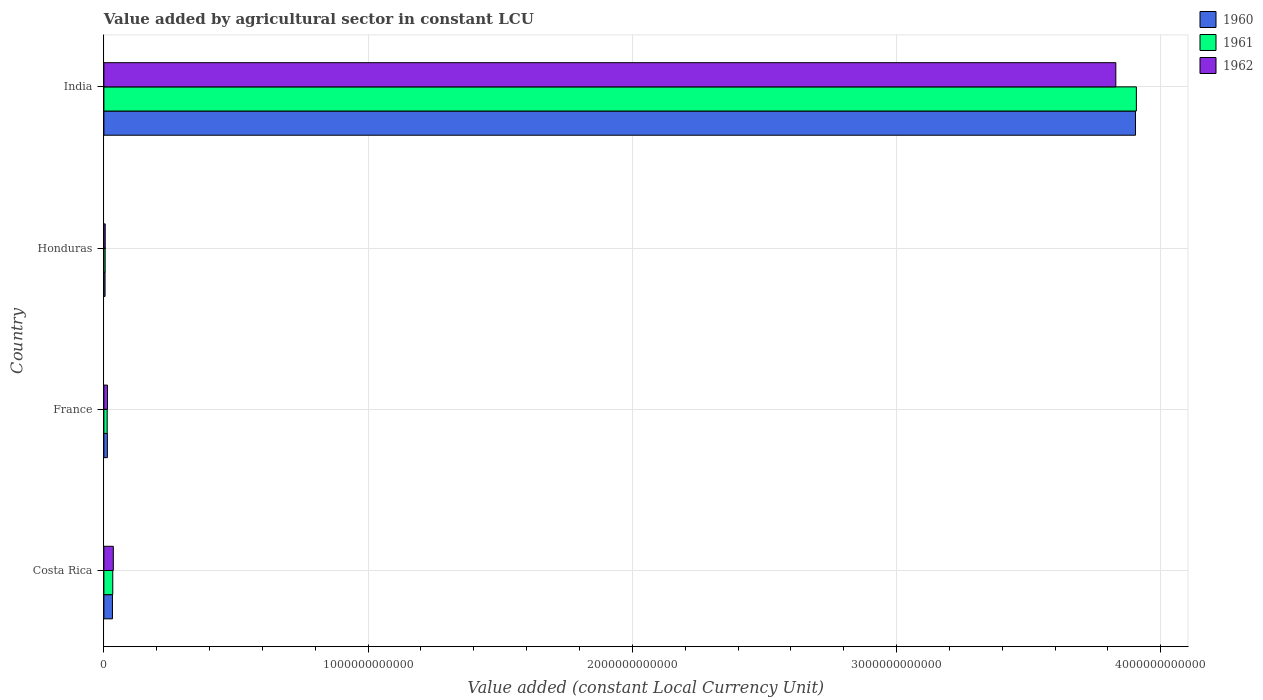Are the number of bars per tick equal to the number of legend labels?
Give a very brief answer. Yes. In how many cases, is the number of bars for a given country not equal to the number of legend labels?
Your response must be concise. 0. What is the value added by agricultural sector in 1962 in France?
Your answer should be very brief. 1.36e+1. Across all countries, what is the maximum value added by agricultural sector in 1962?
Provide a short and direct response. 3.83e+12. Across all countries, what is the minimum value added by agricultural sector in 1962?
Your answer should be compact. 4.96e+09. In which country was the value added by agricultural sector in 1960 minimum?
Give a very brief answer. Honduras. What is the total value added by agricultural sector in 1961 in the graph?
Provide a short and direct response. 3.96e+12. What is the difference between the value added by agricultural sector in 1961 in France and that in India?
Ensure brevity in your answer.  -3.90e+12. What is the difference between the value added by agricultural sector in 1961 in Honduras and the value added by agricultural sector in 1962 in France?
Your response must be concise. -8.85e+09. What is the average value added by agricultural sector in 1960 per country?
Your answer should be compact. 9.89e+11. What is the difference between the value added by agricultural sector in 1961 and value added by agricultural sector in 1960 in France?
Keep it short and to the point. -6.84e+08. In how many countries, is the value added by agricultural sector in 1960 greater than 1600000000000 LCU?
Offer a very short reply. 1. What is the ratio of the value added by agricultural sector in 1961 in France to that in Honduras?
Provide a short and direct response. 2.64. Is the value added by agricultural sector in 1962 in Costa Rica less than that in Honduras?
Your answer should be very brief. No. Is the difference between the value added by agricultural sector in 1961 in France and India greater than the difference between the value added by agricultural sector in 1960 in France and India?
Provide a succinct answer. No. What is the difference between the highest and the second highest value added by agricultural sector in 1961?
Ensure brevity in your answer.  3.87e+12. What is the difference between the highest and the lowest value added by agricultural sector in 1961?
Provide a short and direct response. 3.90e+12. Is the sum of the value added by agricultural sector in 1962 in France and India greater than the maximum value added by agricultural sector in 1960 across all countries?
Offer a very short reply. No. What does the 3rd bar from the top in France represents?
Your response must be concise. 1960. What does the 1st bar from the bottom in Costa Rica represents?
Provide a succinct answer. 1960. Is it the case that in every country, the sum of the value added by agricultural sector in 1960 and value added by agricultural sector in 1961 is greater than the value added by agricultural sector in 1962?
Offer a very short reply. Yes. How many bars are there?
Your answer should be compact. 12. Are all the bars in the graph horizontal?
Offer a very short reply. Yes. How many countries are there in the graph?
Your response must be concise. 4. What is the difference between two consecutive major ticks on the X-axis?
Give a very brief answer. 1.00e+12. Does the graph contain grids?
Your response must be concise. Yes. Where does the legend appear in the graph?
Your answer should be very brief. Top right. What is the title of the graph?
Provide a succinct answer. Value added by agricultural sector in constant LCU. Does "1962" appear as one of the legend labels in the graph?
Provide a short and direct response. Yes. What is the label or title of the X-axis?
Offer a terse response. Value added (constant Local Currency Unit). What is the label or title of the Y-axis?
Your answer should be compact. Country. What is the Value added (constant Local Currency Unit) of 1960 in Costa Rica?
Give a very brief answer. 3.24e+1. What is the Value added (constant Local Currency Unit) in 1961 in Costa Rica?
Your answer should be compact. 3.36e+1. What is the Value added (constant Local Currency Unit) of 1962 in Costa Rica?
Make the answer very short. 3.57e+1. What is the Value added (constant Local Currency Unit) in 1960 in France?
Ensure brevity in your answer.  1.32e+1. What is the Value added (constant Local Currency Unit) of 1961 in France?
Your response must be concise. 1.25e+1. What is the Value added (constant Local Currency Unit) of 1962 in France?
Give a very brief answer. 1.36e+1. What is the Value added (constant Local Currency Unit) in 1960 in Honduras?
Provide a succinct answer. 4.44e+09. What is the Value added (constant Local Currency Unit) in 1961 in Honduras?
Provide a succinct answer. 4.73e+09. What is the Value added (constant Local Currency Unit) in 1962 in Honduras?
Provide a short and direct response. 4.96e+09. What is the Value added (constant Local Currency Unit) of 1960 in India?
Your answer should be very brief. 3.90e+12. What is the Value added (constant Local Currency Unit) in 1961 in India?
Offer a very short reply. 3.91e+12. What is the Value added (constant Local Currency Unit) in 1962 in India?
Offer a very short reply. 3.83e+12. Across all countries, what is the maximum Value added (constant Local Currency Unit) in 1960?
Offer a terse response. 3.90e+12. Across all countries, what is the maximum Value added (constant Local Currency Unit) in 1961?
Your answer should be compact. 3.91e+12. Across all countries, what is the maximum Value added (constant Local Currency Unit) of 1962?
Provide a short and direct response. 3.83e+12. Across all countries, what is the minimum Value added (constant Local Currency Unit) of 1960?
Your answer should be compact. 4.44e+09. Across all countries, what is the minimum Value added (constant Local Currency Unit) of 1961?
Your answer should be very brief. 4.73e+09. Across all countries, what is the minimum Value added (constant Local Currency Unit) of 1962?
Provide a short and direct response. 4.96e+09. What is the total Value added (constant Local Currency Unit) in 1960 in the graph?
Ensure brevity in your answer.  3.95e+12. What is the total Value added (constant Local Currency Unit) of 1961 in the graph?
Provide a short and direct response. 3.96e+12. What is the total Value added (constant Local Currency Unit) of 1962 in the graph?
Offer a very short reply. 3.88e+12. What is the difference between the Value added (constant Local Currency Unit) in 1960 in Costa Rica and that in France?
Offer a terse response. 1.92e+1. What is the difference between the Value added (constant Local Currency Unit) in 1961 in Costa Rica and that in France?
Give a very brief answer. 2.11e+1. What is the difference between the Value added (constant Local Currency Unit) of 1962 in Costa Rica and that in France?
Ensure brevity in your answer.  2.21e+1. What is the difference between the Value added (constant Local Currency Unit) of 1960 in Costa Rica and that in Honduras?
Offer a terse response. 2.80e+1. What is the difference between the Value added (constant Local Currency Unit) in 1961 in Costa Rica and that in Honduras?
Your answer should be very brief. 2.89e+1. What is the difference between the Value added (constant Local Currency Unit) in 1962 in Costa Rica and that in Honduras?
Your answer should be compact. 3.07e+1. What is the difference between the Value added (constant Local Currency Unit) of 1960 in Costa Rica and that in India?
Keep it short and to the point. -3.87e+12. What is the difference between the Value added (constant Local Currency Unit) in 1961 in Costa Rica and that in India?
Provide a succinct answer. -3.87e+12. What is the difference between the Value added (constant Local Currency Unit) in 1962 in Costa Rica and that in India?
Provide a short and direct response. -3.79e+12. What is the difference between the Value added (constant Local Currency Unit) in 1960 in France and that in Honduras?
Your answer should be compact. 8.72e+09. What is the difference between the Value added (constant Local Currency Unit) of 1961 in France and that in Honduras?
Provide a succinct answer. 7.74e+09. What is the difference between the Value added (constant Local Currency Unit) in 1962 in France and that in Honduras?
Ensure brevity in your answer.  8.63e+09. What is the difference between the Value added (constant Local Currency Unit) of 1960 in France and that in India?
Your response must be concise. -3.89e+12. What is the difference between the Value added (constant Local Currency Unit) of 1961 in France and that in India?
Offer a very short reply. -3.90e+12. What is the difference between the Value added (constant Local Currency Unit) of 1962 in France and that in India?
Offer a terse response. -3.82e+12. What is the difference between the Value added (constant Local Currency Unit) in 1960 in Honduras and that in India?
Ensure brevity in your answer.  -3.90e+12. What is the difference between the Value added (constant Local Currency Unit) in 1961 in Honduras and that in India?
Your answer should be compact. -3.90e+12. What is the difference between the Value added (constant Local Currency Unit) of 1962 in Honduras and that in India?
Your answer should be very brief. -3.82e+12. What is the difference between the Value added (constant Local Currency Unit) of 1960 in Costa Rica and the Value added (constant Local Currency Unit) of 1961 in France?
Your answer should be compact. 1.99e+1. What is the difference between the Value added (constant Local Currency Unit) of 1960 in Costa Rica and the Value added (constant Local Currency Unit) of 1962 in France?
Your answer should be compact. 1.88e+1. What is the difference between the Value added (constant Local Currency Unit) of 1961 in Costa Rica and the Value added (constant Local Currency Unit) of 1962 in France?
Make the answer very short. 2.00e+1. What is the difference between the Value added (constant Local Currency Unit) in 1960 in Costa Rica and the Value added (constant Local Currency Unit) in 1961 in Honduras?
Your answer should be compact. 2.77e+1. What is the difference between the Value added (constant Local Currency Unit) of 1960 in Costa Rica and the Value added (constant Local Currency Unit) of 1962 in Honduras?
Make the answer very short. 2.74e+1. What is the difference between the Value added (constant Local Currency Unit) of 1961 in Costa Rica and the Value added (constant Local Currency Unit) of 1962 in Honduras?
Provide a succinct answer. 2.86e+1. What is the difference between the Value added (constant Local Currency Unit) in 1960 in Costa Rica and the Value added (constant Local Currency Unit) in 1961 in India?
Offer a very short reply. -3.88e+12. What is the difference between the Value added (constant Local Currency Unit) in 1960 in Costa Rica and the Value added (constant Local Currency Unit) in 1962 in India?
Provide a short and direct response. -3.80e+12. What is the difference between the Value added (constant Local Currency Unit) in 1961 in Costa Rica and the Value added (constant Local Currency Unit) in 1962 in India?
Offer a terse response. -3.80e+12. What is the difference between the Value added (constant Local Currency Unit) of 1960 in France and the Value added (constant Local Currency Unit) of 1961 in Honduras?
Provide a succinct answer. 8.43e+09. What is the difference between the Value added (constant Local Currency Unit) in 1960 in France and the Value added (constant Local Currency Unit) in 1962 in Honduras?
Give a very brief answer. 8.20e+09. What is the difference between the Value added (constant Local Currency Unit) of 1961 in France and the Value added (constant Local Currency Unit) of 1962 in Honduras?
Your response must be concise. 7.52e+09. What is the difference between the Value added (constant Local Currency Unit) of 1960 in France and the Value added (constant Local Currency Unit) of 1961 in India?
Your answer should be compact. -3.89e+12. What is the difference between the Value added (constant Local Currency Unit) of 1960 in France and the Value added (constant Local Currency Unit) of 1962 in India?
Your answer should be very brief. -3.82e+12. What is the difference between the Value added (constant Local Currency Unit) in 1961 in France and the Value added (constant Local Currency Unit) in 1962 in India?
Provide a short and direct response. -3.82e+12. What is the difference between the Value added (constant Local Currency Unit) in 1960 in Honduras and the Value added (constant Local Currency Unit) in 1961 in India?
Provide a short and direct response. -3.90e+12. What is the difference between the Value added (constant Local Currency Unit) in 1960 in Honduras and the Value added (constant Local Currency Unit) in 1962 in India?
Keep it short and to the point. -3.83e+12. What is the difference between the Value added (constant Local Currency Unit) of 1961 in Honduras and the Value added (constant Local Currency Unit) of 1962 in India?
Ensure brevity in your answer.  -3.83e+12. What is the average Value added (constant Local Currency Unit) in 1960 per country?
Give a very brief answer. 9.89e+11. What is the average Value added (constant Local Currency Unit) of 1961 per country?
Make the answer very short. 9.90e+11. What is the average Value added (constant Local Currency Unit) of 1962 per country?
Make the answer very short. 9.71e+11. What is the difference between the Value added (constant Local Currency Unit) of 1960 and Value added (constant Local Currency Unit) of 1961 in Costa Rica?
Ensure brevity in your answer.  -1.19e+09. What is the difference between the Value added (constant Local Currency Unit) in 1960 and Value added (constant Local Currency Unit) in 1962 in Costa Rica?
Offer a very short reply. -3.25e+09. What is the difference between the Value added (constant Local Currency Unit) of 1961 and Value added (constant Local Currency Unit) of 1962 in Costa Rica?
Your answer should be very brief. -2.06e+09. What is the difference between the Value added (constant Local Currency Unit) in 1960 and Value added (constant Local Currency Unit) in 1961 in France?
Your answer should be very brief. 6.84e+08. What is the difference between the Value added (constant Local Currency Unit) of 1960 and Value added (constant Local Currency Unit) of 1962 in France?
Ensure brevity in your answer.  -4.23e+08. What is the difference between the Value added (constant Local Currency Unit) in 1961 and Value added (constant Local Currency Unit) in 1962 in France?
Offer a terse response. -1.11e+09. What is the difference between the Value added (constant Local Currency Unit) of 1960 and Value added (constant Local Currency Unit) of 1961 in Honduras?
Keep it short and to the point. -2.90e+08. What is the difference between the Value added (constant Local Currency Unit) in 1960 and Value added (constant Local Currency Unit) in 1962 in Honduras?
Give a very brief answer. -5.15e+08. What is the difference between the Value added (constant Local Currency Unit) of 1961 and Value added (constant Local Currency Unit) of 1962 in Honduras?
Your answer should be very brief. -2.25e+08. What is the difference between the Value added (constant Local Currency Unit) of 1960 and Value added (constant Local Currency Unit) of 1961 in India?
Provide a short and direct response. -3.29e+09. What is the difference between the Value added (constant Local Currency Unit) of 1960 and Value added (constant Local Currency Unit) of 1962 in India?
Ensure brevity in your answer.  7.44e+1. What is the difference between the Value added (constant Local Currency Unit) in 1961 and Value added (constant Local Currency Unit) in 1962 in India?
Ensure brevity in your answer.  7.77e+1. What is the ratio of the Value added (constant Local Currency Unit) of 1960 in Costa Rica to that in France?
Your response must be concise. 2.46. What is the ratio of the Value added (constant Local Currency Unit) in 1961 in Costa Rica to that in France?
Ensure brevity in your answer.  2.69. What is the ratio of the Value added (constant Local Currency Unit) in 1962 in Costa Rica to that in France?
Offer a very short reply. 2.63. What is the ratio of the Value added (constant Local Currency Unit) in 1960 in Costa Rica to that in Honduras?
Offer a terse response. 7.3. What is the ratio of the Value added (constant Local Currency Unit) in 1961 in Costa Rica to that in Honduras?
Offer a terse response. 7.1. What is the ratio of the Value added (constant Local Currency Unit) of 1962 in Costa Rica to that in Honduras?
Offer a very short reply. 7.2. What is the ratio of the Value added (constant Local Currency Unit) of 1960 in Costa Rica to that in India?
Offer a terse response. 0.01. What is the ratio of the Value added (constant Local Currency Unit) in 1961 in Costa Rica to that in India?
Make the answer very short. 0.01. What is the ratio of the Value added (constant Local Currency Unit) of 1962 in Costa Rica to that in India?
Your answer should be very brief. 0.01. What is the ratio of the Value added (constant Local Currency Unit) in 1960 in France to that in Honduras?
Your response must be concise. 2.96. What is the ratio of the Value added (constant Local Currency Unit) of 1961 in France to that in Honduras?
Keep it short and to the point. 2.64. What is the ratio of the Value added (constant Local Currency Unit) in 1962 in France to that in Honduras?
Ensure brevity in your answer.  2.74. What is the ratio of the Value added (constant Local Currency Unit) in 1960 in France to that in India?
Give a very brief answer. 0. What is the ratio of the Value added (constant Local Currency Unit) of 1961 in France to that in India?
Your answer should be very brief. 0. What is the ratio of the Value added (constant Local Currency Unit) in 1962 in France to that in India?
Offer a very short reply. 0. What is the ratio of the Value added (constant Local Currency Unit) of 1960 in Honduras to that in India?
Ensure brevity in your answer.  0. What is the ratio of the Value added (constant Local Currency Unit) in 1961 in Honduras to that in India?
Offer a very short reply. 0. What is the ratio of the Value added (constant Local Currency Unit) of 1962 in Honduras to that in India?
Give a very brief answer. 0. What is the difference between the highest and the second highest Value added (constant Local Currency Unit) in 1960?
Provide a short and direct response. 3.87e+12. What is the difference between the highest and the second highest Value added (constant Local Currency Unit) of 1961?
Your answer should be compact. 3.87e+12. What is the difference between the highest and the second highest Value added (constant Local Currency Unit) of 1962?
Keep it short and to the point. 3.79e+12. What is the difference between the highest and the lowest Value added (constant Local Currency Unit) of 1960?
Provide a short and direct response. 3.90e+12. What is the difference between the highest and the lowest Value added (constant Local Currency Unit) of 1961?
Give a very brief answer. 3.90e+12. What is the difference between the highest and the lowest Value added (constant Local Currency Unit) of 1962?
Offer a very short reply. 3.82e+12. 